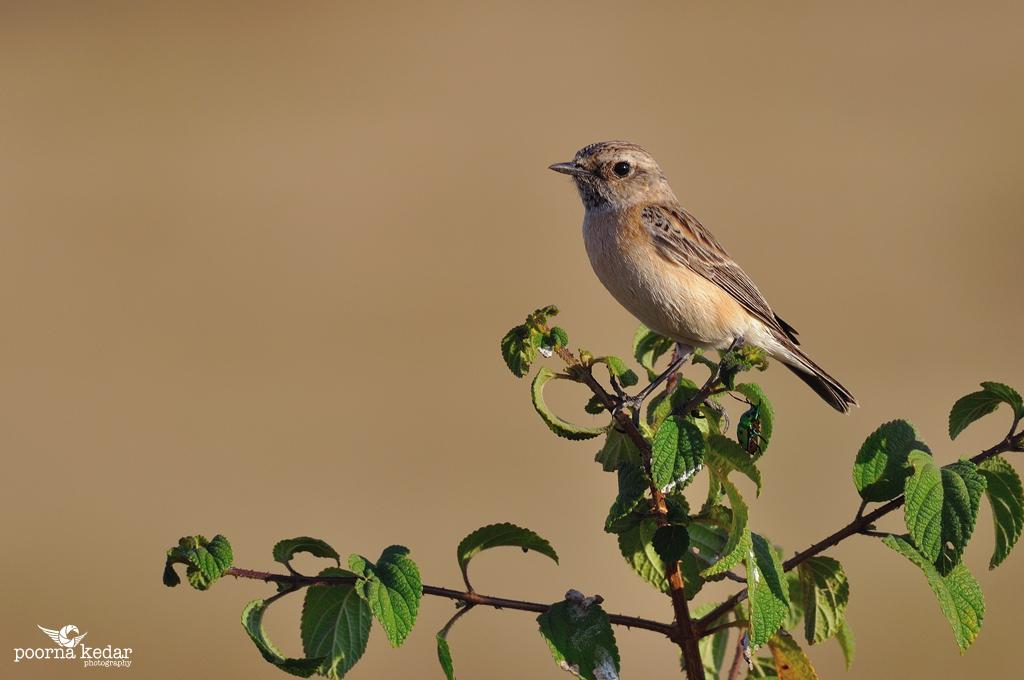What type of animal is present in the image? There is a bird in the image. Where is the bird located? The bird is on a plant. What type of business does the governor own, as seen in the image? There is no mention of a business or a governor in the image; it features a bird on a plant. 